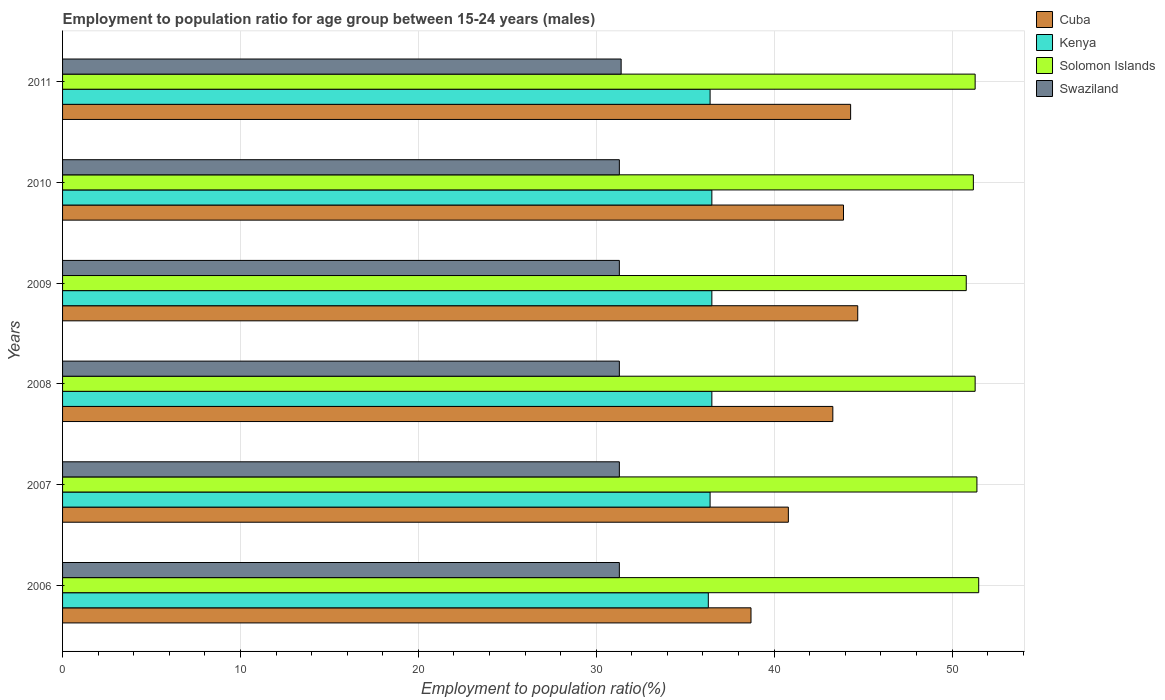Are the number of bars per tick equal to the number of legend labels?
Offer a terse response. Yes. Are the number of bars on each tick of the Y-axis equal?
Your answer should be very brief. Yes. How many bars are there on the 5th tick from the top?
Provide a short and direct response. 4. How many bars are there on the 6th tick from the bottom?
Make the answer very short. 4. What is the employment to population ratio in Kenya in 2007?
Offer a very short reply. 36.4. Across all years, what is the maximum employment to population ratio in Swaziland?
Offer a very short reply. 31.4. Across all years, what is the minimum employment to population ratio in Solomon Islands?
Offer a very short reply. 50.8. In which year was the employment to population ratio in Solomon Islands maximum?
Keep it short and to the point. 2006. What is the total employment to population ratio in Cuba in the graph?
Provide a succinct answer. 255.7. What is the difference between the employment to population ratio in Cuba in 2006 and that in 2011?
Offer a very short reply. -5.6. What is the difference between the employment to population ratio in Cuba in 2006 and the employment to population ratio in Kenya in 2008?
Provide a succinct answer. 2.2. What is the average employment to population ratio in Kenya per year?
Your response must be concise. 36.43. In the year 2009, what is the difference between the employment to population ratio in Swaziland and employment to population ratio in Solomon Islands?
Ensure brevity in your answer.  -19.5. What is the ratio of the employment to population ratio in Cuba in 2006 to that in 2008?
Provide a succinct answer. 0.89. What is the difference between the highest and the second highest employment to population ratio in Solomon Islands?
Keep it short and to the point. 0.1. Is the sum of the employment to population ratio in Swaziland in 2008 and 2009 greater than the maximum employment to population ratio in Cuba across all years?
Make the answer very short. Yes. What does the 1st bar from the top in 2007 represents?
Offer a terse response. Swaziland. What does the 1st bar from the bottom in 2011 represents?
Your response must be concise. Cuba. Is it the case that in every year, the sum of the employment to population ratio in Cuba and employment to population ratio in Solomon Islands is greater than the employment to population ratio in Swaziland?
Your answer should be compact. Yes. Are all the bars in the graph horizontal?
Make the answer very short. Yes. How many years are there in the graph?
Your answer should be very brief. 6. Where does the legend appear in the graph?
Your answer should be very brief. Top right. How are the legend labels stacked?
Your answer should be compact. Vertical. What is the title of the graph?
Make the answer very short. Employment to population ratio for age group between 15-24 years (males). What is the Employment to population ratio(%) of Cuba in 2006?
Your answer should be compact. 38.7. What is the Employment to population ratio(%) of Kenya in 2006?
Keep it short and to the point. 36.3. What is the Employment to population ratio(%) in Solomon Islands in 2006?
Provide a succinct answer. 51.5. What is the Employment to population ratio(%) of Swaziland in 2006?
Your answer should be very brief. 31.3. What is the Employment to population ratio(%) of Cuba in 2007?
Keep it short and to the point. 40.8. What is the Employment to population ratio(%) of Kenya in 2007?
Make the answer very short. 36.4. What is the Employment to population ratio(%) of Solomon Islands in 2007?
Your answer should be very brief. 51.4. What is the Employment to population ratio(%) of Swaziland in 2007?
Your answer should be compact. 31.3. What is the Employment to population ratio(%) in Cuba in 2008?
Your answer should be very brief. 43.3. What is the Employment to population ratio(%) of Kenya in 2008?
Offer a terse response. 36.5. What is the Employment to population ratio(%) in Solomon Islands in 2008?
Ensure brevity in your answer.  51.3. What is the Employment to population ratio(%) in Swaziland in 2008?
Provide a short and direct response. 31.3. What is the Employment to population ratio(%) of Cuba in 2009?
Your answer should be compact. 44.7. What is the Employment to population ratio(%) in Kenya in 2009?
Provide a succinct answer. 36.5. What is the Employment to population ratio(%) of Solomon Islands in 2009?
Make the answer very short. 50.8. What is the Employment to population ratio(%) in Swaziland in 2009?
Give a very brief answer. 31.3. What is the Employment to population ratio(%) of Cuba in 2010?
Your response must be concise. 43.9. What is the Employment to population ratio(%) of Kenya in 2010?
Make the answer very short. 36.5. What is the Employment to population ratio(%) of Solomon Islands in 2010?
Your response must be concise. 51.2. What is the Employment to population ratio(%) of Swaziland in 2010?
Your response must be concise. 31.3. What is the Employment to population ratio(%) of Cuba in 2011?
Your response must be concise. 44.3. What is the Employment to population ratio(%) of Kenya in 2011?
Give a very brief answer. 36.4. What is the Employment to population ratio(%) in Solomon Islands in 2011?
Keep it short and to the point. 51.3. What is the Employment to population ratio(%) in Swaziland in 2011?
Your answer should be very brief. 31.4. Across all years, what is the maximum Employment to population ratio(%) in Cuba?
Provide a short and direct response. 44.7. Across all years, what is the maximum Employment to population ratio(%) in Kenya?
Your answer should be very brief. 36.5. Across all years, what is the maximum Employment to population ratio(%) of Solomon Islands?
Make the answer very short. 51.5. Across all years, what is the maximum Employment to population ratio(%) of Swaziland?
Offer a terse response. 31.4. Across all years, what is the minimum Employment to population ratio(%) in Cuba?
Give a very brief answer. 38.7. Across all years, what is the minimum Employment to population ratio(%) of Kenya?
Offer a very short reply. 36.3. Across all years, what is the minimum Employment to population ratio(%) in Solomon Islands?
Your answer should be very brief. 50.8. Across all years, what is the minimum Employment to population ratio(%) of Swaziland?
Offer a very short reply. 31.3. What is the total Employment to population ratio(%) in Cuba in the graph?
Provide a short and direct response. 255.7. What is the total Employment to population ratio(%) in Kenya in the graph?
Give a very brief answer. 218.6. What is the total Employment to population ratio(%) in Solomon Islands in the graph?
Provide a short and direct response. 307.5. What is the total Employment to population ratio(%) in Swaziland in the graph?
Your answer should be compact. 187.9. What is the difference between the Employment to population ratio(%) in Cuba in 2006 and that in 2007?
Offer a terse response. -2.1. What is the difference between the Employment to population ratio(%) of Kenya in 2006 and that in 2007?
Give a very brief answer. -0.1. What is the difference between the Employment to population ratio(%) in Solomon Islands in 2006 and that in 2007?
Ensure brevity in your answer.  0.1. What is the difference between the Employment to population ratio(%) of Swaziland in 2006 and that in 2007?
Your answer should be compact. 0. What is the difference between the Employment to population ratio(%) in Kenya in 2006 and that in 2008?
Ensure brevity in your answer.  -0.2. What is the difference between the Employment to population ratio(%) of Kenya in 2006 and that in 2009?
Your answer should be compact. -0.2. What is the difference between the Employment to population ratio(%) of Solomon Islands in 2006 and that in 2009?
Your answer should be compact. 0.7. What is the difference between the Employment to population ratio(%) in Swaziland in 2006 and that in 2009?
Give a very brief answer. 0. What is the difference between the Employment to population ratio(%) of Cuba in 2006 and that in 2010?
Your response must be concise. -5.2. What is the difference between the Employment to population ratio(%) in Kenya in 2006 and that in 2010?
Give a very brief answer. -0.2. What is the difference between the Employment to population ratio(%) in Cuba in 2006 and that in 2011?
Make the answer very short. -5.6. What is the difference between the Employment to population ratio(%) of Kenya in 2006 and that in 2011?
Provide a succinct answer. -0.1. What is the difference between the Employment to population ratio(%) in Swaziland in 2006 and that in 2011?
Offer a very short reply. -0.1. What is the difference between the Employment to population ratio(%) in Solomon Islands in 2007 and that in 2008?
Your response must be concise. 0.1. What is the difference between the Employment to population ratio(%) of Cuba in 2007 and that in 2009?
Ensure brevity in your answer.  -3.9. What is the difference between the Employment to population ratio(%) of Swaziland in 2007 and that in 2009?
Your response must be concise. 0. What is the difference between the Employment to population ratio(%) in Cuba in 2007 and that in 2011?
Make the answer very short. -3.5. What is the difference between the Employment to population ratio(%) in Kenya in 2007 and that in 2011?
Give a very brief answer. 0. What is the difference between the Employment to population ratio(%) of Swaziland in 2007 and that in 2011?
Keep it short and to the point. -0.1. What is the difference between the Employment to population ratio(%) in Cuba in 2008 and that in 2009?
Keep it short and to the point. -1.4. What is the difference between the Employment to population ratio(%) in Kenya in 2008 and that in 2009?
Provide a short and direct response. 0. What is the difference between the Employment to population ratio(%) of Cuba in 2008 and that in 2010?
Ensure brevity in your answer.  -0.6. What is the difference between the Employment to population ratio(%) in Kenya in 2008 and that in 2010?
Make the answer very short. 0. What is the difference between the Employment to population ratio(%) in Solomon Islands in 2008 and that in 2010?
Provide a succinct answer. 0.1. What is the difference between the Employment to population ratio(%) in Cuba in 2008 and that in 2011?
Ensure brevity in your answer.  -1. What is the difference between the Employment to population ratio(%) in Swaziland in 2008 and that in 2011?
Make the answer very short. -0.1. What is the difference between the Employment to population ratio(%) of Kenya in 2009 and that in 2010?
Ensure brevity in your answer.  0. What is the difference between the Employment to population ratio(%) in Solomon Islands in 2009 and that in 2010?
Provide a short and direct response. -0.4. What is the difference between the Employment to population ratio(%) in Cuba in 2009 and that in 2011?
Keep it short and to the point. 0.4. What is the difference between the Employment to population ratio(%) of Kenya in 2009 and that in 2011?
Offer a terse response. 0.1. What is the difference between the Employment to population ratio(%) of Solomon Islands in 2009 and that in 2011?
Your response must be concise. -0.5. What is the difference between the Employment to population ratio(%) of Solomon Islands in 2010 and that in 2011?
Your response must be concise. -0.1. What is the difference between the Employment to population ratio(%) in Swaziland in 2010 and that in 2011?
Offer a very short reply. -0.1. What is the difference between the Employment to population ratio(%) of Cuba in 2006 and the Employment to population ratio(%) of Swaziland in 2007?
Ensure brevity in your answer.  7.4. What is the difference between the Employment to population ratio(%) in Kenya in 2006 and the Employment to population ratio(%) in Solomon Islands in 2007?
Your answer should be very brief. -15.1. What is the difference between the Employment to population ratio(%) of Kenya in 2006 and the Employment to population ratio(%) of Swaziland in 2007?
Your answer should be compact. 5. What is the difference between the Employment to population ratio(%) in Solomon Islands in 2006 and the Employment to population ratio(%) in Swaziland in 2007?
Keep it short and to the point. 20.2. What is the difference between the Employment to population ratio(%) in Solomon Islands in 2006 and the Employment to population ratio(%) in Swaziland in 2008?
Keep it short and to the point. 20.2. What is the difference between the Employment to population ratio(%) of Cuba in 2006 and the Employment to population ratio(%) of Kenya in 2009?
Your answer should be very brief. 2.2. What is the difference between the Employment to population ratio(%) of Cuba in 2006 and the Employment to population ratio(%) of Swaziland in 2009?
Offer a terse response. 7.4. What is the difference between the Employment to population ratio(%) of Kenya in 2006 and the Employment to population ratio(%) of Solomon Islands in 2009?
Provide a short and direct response. -14.5. What is the difference between the Employment to population ratio(%) in Solomon Islands in 2006 and the Employment to population ratio(%) in Swaziland in 2009?
Offer a very short reply. 20.2. What is the difference between the Employment to population ratio(%) in Cuba in 2006 and the Employment to population ratio(%) in Kenya in 2010?
Make the answer very short. 2.2. What is the difference between the Employment to population ratio(%) in Cuba in 2006 and the Employment to population ratio(%) in Swaziland in 2010?
Your answer should be very brief. 7.4. What is the difference between the Employment to population ratio(%) of Kenya in 2006 and the Employment to population ratio(%) of Solomon Islands in 2010?
Offer a very short reply. -14.9. What is the difference between the Employment to population ratio(%) of Kenya in 2006 and the Employment to population ratio(%) of Swaziland in 2010?
Your response must be concise. 5. What is the difference between the Employment to population ratio(%) of Solomon Islands in 2006 and the Employment to population ratio(%) of Swaziland in 2010?
Give a very brief answer. 20.2. What is the difference between the Employment to population ratio(%) of Cuba in 2006 and the Employment to population ratio(%) of Kenya in 2011?
Keep it short and to the point. 2.3. What is the difference between the Employment to population ratio(%) of Cuba in 2006 and the Employment to population ratio(%) of Swaziland in 2011?
Offer a very short reply. 7.3. What is the difference between the Employment to population ratio(%) in Solomon Islands in 2006 and the Employment to population ratio(%) in Swaziland in 2011?
Your answer should be compact. 20.1. What is the difference between the Employment to population ratio(%) of Cuba in 2007 and the Employment to population ratio(%) of Kenya in 2008?
Offer a terse response. 4.3. What is the difference between the Employment to population ratio(%) in Cuba in 2007 and the Employment to population ratio(%) in Solomon Islands in 2008?
Provide a succinct answer. -10.5. What is the difference between the Employment to population ratio(%) in Cuba in 2007 and the Employment to population ratio(%) in Swaziland in 2008?
Ensure brevity in your answer.  9.5. What is the difference between the Employment to population ratio(%) in Kenya in 2007 and the Employment to population ratio(%) in Solomon Islands in 2008?
Offer a terse response. -14.9. What is the difference between the Employment to population ratio(%) of Solomon Islands in 2007 and the Employment to population ratio(%) of Swaziland in 2008?
Offer a very short reply. 20.1. What is the difference between the Employment to population ratio(%) of Kenya in 2007 and the Employment to population ratio(%) of Solomon Islands in 2009?
Your response must be concise. -14.4. What is the difference between the Employment to population ratio(%) of Solomon Islands in 2007 and the Employment to population ratio(%) of Swaziland in 2009?
Ensure brevity in your answer.  20.1. What is the difference between the Employment to population ratio(%) in Cuba in 2007 and the Employment to population ratio(%) in Kenya in 2010?
Give a very brief answer. 4.3. What is the difference between the Employment to population ratio(%) of Kenya in 2007 and the Employment to population ratio(%) of Solomon Islands in 2010?
Ensure brevity in your answer.  -14.8. What is the difference between the Employment to population ratio(%) of Solomon Islands in 2007 and the Employment to population ratio(%) of Swaziland in 2010?
Offer a very short reply. 20.1. What is the difference between the Employment to population ratio(%) of Kenya in 2007 and the Employment to population ratio(%) of Solomon Islands in 2011?
Offer a terse response. -14.9. What is the difference between the Employment to population ratio(%) in Kenya in 2007 and the Employment to population ratio(%) in Swaziland in 2011?
Ensure brevity in your answer.  5. What is the difference between the Employment to population ratio(%) in Solomon Islands in 2007 and the Employment to population ratio(%) in Swaziland in 2011?
Give a very brief answer. 20. What is the difference between the Employment to population ratio(%) in Cuba in 2008 and the Employment to population ratio(%) in Swaziland in 2009?
Offer a very short reply. 12. What is the difference between the Employment to population ratio(%) in Kenya in 2008 and the Employment to population ratio(%) in Solomon Islands in 2009?
Your answer should be compact. -14.3. What is the difference between the Employment to population ratio(%) in Cuba in 2008 and the Employment to population ratio(%) in Kenya in 2010?
Give a very brief answer. 6.8. What is the difference between the Employment to population ratio(%) of Kenya in 2008 and the Employment to population ratio(%) of Solomon Islands in 2010?
Provide a succinct answer. -14.7. What is the difference between the Employment to population ratio(%) in Kenya in 2008 and the Employment to population ratio(%) in Swaziland in 2010?
Keep it short and to the point. 5.2. What is the difference between the Employment to population ratio(%) in Cuba in 2008 and the Employment to population ratio(%) in Kenya in 2011?
Your response must be concise. 6.9. What is the difference between the Employment to population ratio(%) in Cuba in 2008 and the Employment to population ratio(%) in Swaziland in 2011?
Provide a short and direct response. 11.9. What is the difference between the Employment to population ratio(%) of Kenya in 2008 and the Employment to population ratio(%) of Solomon Islands in 2011?
Give a very brief answer. -14.8. What is the difference between the Employment to population ratio(%) of Kenya in 2008 and the Employment to population ratio(%) of Swaziland in 2011?
Make the answer very short. 5.1. What is the difference between the Employment to population ratio(%) of Solomon Islands in 2008 and the Employment to population ratio(%) of Swaziland in 2011?
Offer a terse response. 19.9. What is the difference between the Employment to population ratio(%) of Cuba in 2009 and the Employment to population ratio(%) of Solomon Islands in 2010?
Give a very brief answer. -6.5. What is the difference between the Employment to population ratio(%) in Cuba in 2009 and the Employment to population ratio(%) in Swaziland in 2010?
Offer a terse response. 13.4. What is the difference between the Employment to population ratio(%) of Kenya in 2009 and the Employment to population ratio(%) of Solomon Islands in 2010?
Your response must be concise. -14.7. What is the difference between the Employment to population ratio(%) in Kenya in 2009 and the Employment to population ratio(%) in Swaziland in 2010?
Your answer should be compact. 5.2. What is the difference between the Employment to population ratio(%) of Solomon Islands in 2009 and the Employment to population ratio(%) of Swaziland in 2010?
Offer a terse response. 19.5. What is the difference between the Employment to population ratio(%) in Cuba in 2009 and the Employment to population ratio(%) in Kenya in 2011?
Your answer should be very brief. 8.3. What is the difference between the Employment to population ratio(%) in Cuba in 2009 and the Employment to population ratio(%) in Solomon Islands in 2011?
Make the answer very short. -6.6. What is the difference between the Employment to population ratio(%) of Cuba in 2009 and the Employment to population ratio(%) of Swaziland in 2011?
Make the answer very short. 13.3. What is the difference between the Employment to population ratio(%) in Kenya in 2009 and the Employment to population ratio(%) in Solomon Islands in 2011?
Keep it short and to the point. -14.8. What is the difference between the Employment to population ratio(%) of Kenya in 2009 and the Employment to population ratio(%) of Swaziland in 2011?
Your answer should be compact. 5.1. What is the difference between the Employment to population ratio(%) of Kenya in 2010 and the Employment to population ratio(%) of Solomon Islands in 2011?
Keep it short and to the point. -14.8. What is the difference between the Employment to population ratio(%) in Kenya in 2010 and the Employment to population ratio(%) in Swaziland in 2011?
Provide a succinct answer. 5.1. What is the difference between the Employment to population ratio(%) of Solomon Islands in 2010 and the Employment to population ratio(%) of Swaziland in 2011?
Give a very brief answer. 19.8. What is the average Employment to population ratio(%) in Cuba per year?
Your answer should be compact. 42.62. What is the average Employment to population ratio(%) of Kenya per year?
Offer a terse response. 36.43. What is the average Employment to population ratio(%) in Solomon Islands per year?
Keep it short and to the point. 51.25. What is the average Employment to population ratio(%) of Swaziland per year?
Offer a very short reply. 31.32. In the year 2006, what is the difference between the Employment to population ratio(%) in Cuba and Employment to population ratio(%) in Kenya?
Give a very brief answer. 2.4. In the year 2006, what is the difference between the Employment to population ratio(%) in Cuba and Employment to population ratio(%) in Solomon Islands?
Ensure brevity in your answer.  -12.8. In the year 2006, what is the difference between the Employment to population ratio(%) of Kenya and Employment to population ratio(%) of Solomon Islands?
Your answer should be compact. -15.2. In the year 2006, what is the difference between the Employment to population ratio(%) of Solomon Islands and Employment to population ratio(%) of Swaziland?
Your answer should be compact. 20.2. In the year 2007, what is the difference between the Employment to population ratio(%) in Cuba and Employment to population ratio(%) in Kenya?
Make the answer very short. 4.4. In the year 2007, what is the difference between the Employment to population ratio(%) in Solomon Islands and Employment to population ratio(%) in Swaziland?
Ensure brevity in your answer.  20.1. In the year 2008, what is the difference between the Employment to population ratio(%) of Kenya and Employment to population ratio(%) of Solomon Islands?
Provide a short and direct response. -14.8. In the year 2008, what is the difference between the Employment to population ratio(%) in Kenya and Employment to population ratio(%) in Swaziland?
Your answer should be very brief. 5.2. In the year 2008, what is the difference between the Employment to population ratio(%) of Solomon Islands and Employment to population ratio(%) of Swaziland?
Offer a very short reply. 20. In the year 2009, what is the difference between the Employment to population ratio(%) in Cuba and Employment to population ratio(%) in Kenya?
Your answer should be very brief. 8.2. In the year 2009, what is the difference between the Employment to population ratio(%) in Cuba and Employment to population ratio(%) in Solomon Islands?
Keep it short and to the point. -6.1. In the year 2009, what is the difference between the Employment to population ratio(%) in Cuba and Employment to population ratio(%) in Swaziland?
Offer a very short reply. 13.4. In the year 2009, what is the difference between the Employment to population ratio(%) in Kenya and Employment to population ratio(%) in Solomon Islands?
Give a very brief answer. -14.3. In the year 2009, what is the difference between the Employment to population ratio(%) of Kenya and Employment to population ratio(%) of Swaziland?
Offer a very short reply. 5.2. In the year 2010, what is the difference between the Employment to population ratio(%) of Cuba and Employment to population ratio(%) of Solomon Islands?
Offer a terse response. -7.3. In the year 2010, what is the difference between the Employment to population ratio(%) in Kenya and Employment to population ratio(%) in Solomon Islands?
Give a very brief answer. -14.7. In the year 2010, what is the difference between the Employment to population ratio(%) in Solomon Islands and Employment to population ratio(%) in Swaziland?
Provide a succinct answer. 19.9. In the year 2011, what is the difference between the Employment to population ratio(%) of Kenya and Employment to population ratio(%) of Solomon Islands?
Keep it short and to the point. -14.9. What is the ratio of the Employment to population ratio(%) of Cuba in 2006 to that in 2007?
Your answer should be very brief. 0.95. What is the ratio of the Employment to population ratio(%) in Solomon Islands in 2006 to that in 2007?
Keep it short and to the point. 1. What is the ratio of the Employment to population ratio(%) in Swaziland in 2006 to that in 2007?
Keep it short and to the point. 1. What is the ratio of the Employment to population ratio(%) in Cuba in 2006 to that in 2008?
Offer a terse response. 0.89. What is the ratio of the Employment to population ratio(%) in Cuba in 2006 to that in 2009?
Your answer should be very brief. 0.87. What is the ratio of the Employment to population ratio(%) in Kenya in 2006 to that in 2009?
Keep it short and to the point. 0.99. What is the ratio of the Employment to population ratio(%) in Solomon Islands in 2006 to that in 2009?
Give a very brief answer. 1.01. What is the ratio of the Employment to population ratio(%) of Swaziland in 2006 to that in 2009?
Offer a terse response. 1. What is the ratio of the Employment to population ratio(%) in Cuba in 2006 to that in 2010?
Provide a succinct answer. 0.88. What is the ratio of the Employment to population ratio(%) of Solomon Islands in 2006 to that in 2010?
Offer a very short reply. 1.01. What is the ratio of the Employment to population ratio(%) in Cuba in 2006 to that in 2011?
Your answer should be very brief. 0.87. What is the ratio of the Employment to population ratio(%) of Kenya in 2006 to that in 2011?
Keep it short and to the point. 1. What is the ratio of the Employment to population ratio(%) in Swaziland in 2006 to that in 2011?
Ensure brevity in your answer.  1. What is the ratio of the Employment to population ratio(%) of Cuba in 2007 to that in 2008?
Ensure brevity in your answer.  0.94. What is the ratio of the Employment to population ratio(%) of Swaziland in 2007 to that in 2008?
Your answer should be compact. 1. What is the ratio of the Employment to population ratio(%) of Cuba in 2007 to that in 2009?
Make the answer very short. 0.91. What is the ratio of the Employment to population ratio(%) of Kenya in 2007 to that in 2009?
Give a very brief answer. 1. What is the ratio of the Employment to population ratio(%) in Solomon Islands in 2007 to that in 2009?
Your answer should be very brief. 1.01. What is the ratio of the Employment to population ratio(%) in Swaziland in 2007 to that in 2009?
Offer a very short reply. 1. What is the ratio of the Employment to population ratio(%) of Cuba in 2007 to that in 2010?
Provide a succinct answer. 0.93. What is the ratio of the Employment to population ratio(%) of Swaziland in 2007 to that in 2010?
Offer a terse response. 1. What is the ratio of the Employment to population ratio(%) in Cuba in 2007 to that in 2011?
Give a very brief answer. 0.92. What is the ratio of the Employment to population ratio(%) in Swaziland in 2007 to that in 2011?
Your response must be concise. 1. What is the ratio of the Employment to population ratio(%) of Cuba in 2008 to that in 2009?
Your response must be concise. 0.97. What is the ratio of the Employment to population ratio(%) of Solomon Islands in 2008 to that in 2009?
Make the answer very short. 1.01. What is the ratio of the Employment to population ratio(%) in Swaziland in 2008 to that in 2009?
Provide a succinct answer. 1. What is the ratio of the Employment to population ratio(%) of Cuba in 2008 to that in 2010?
Ensure brevity in your answer.  0.99. What is the ratio of the Employment to population ratio(%) of Solomon Islands in 2008 to that in 2010?
Keep it short and to the point. 1. What is the ratio of the Employment to population ratio(%) of Cuba in 2008 to that in 2011?
Your answer should be compact. 0.98. What is the ratio of the Employment to population ratio(%) of Kenya in 2008 to that in 2011?
Offer a terse response. 1. What is the ratio of the Employment to population ratio(%) of Solomon Islands in 2008 to that in 2011?
Give a very brief answer. 1. What is the ratio of the Employment to population ratio(%) of Cuba in 2009 to that in 2010?
Ensure brevity in your answer.  1.02. What is the ratio of the Employment to population ratio(%) in Solomon Islands in 2009 to that in 2010?
Your response must be concise. 0.99. What is the ratio of the Employment to population ratio(%) in Cuba in 2009 to that in 2011?
Your answer should be very brief. 1.01. What is the ratio of the Employment to population ratio(%) of Solomon Islands in 2009 to that in 2011?
Your answer should be very brief. 0.99. What is the ratio of the Employment to population ratio(%) of Cuba in 2010 to that in 2011?
Provide a short and direct response. 0.99. What is the ratio of the Employment to population ratio(%) of Kenya in 2010 to that in 2011?
Make the answer very short. 1. What is the ratio of the Employment to population ratio(%) in Solomon Islands in 2010 to that in 2011?
Provide a short and direct response. 1. What is the ratio of the Employment to population ratio(%) in Swaziland in 2010 to that in 2011?
Your response must be concise. 1. What is the difference between the highest and the second highest Employment to population ratio(%) of Cuba?
Provide a succinct answer. 0.4. What is the difference between the highest and the second highest Employment to population ratio(%) of Kenya?
Provide a short and direct response. 0. What is the difference between the highest and the second highest Employment to population ratio(%) of Solomon Islands?
Keep it short and to the point. 0.1. What is the difference between the highest and the lowest Employment to population ratio(%) of Kenya?
Ensure brevity in your answer.  0.2. What is the difference between the highest and the lowest Employment to population ratio(%) of Swaziland?
Provide a succinct answer. 0.1. 